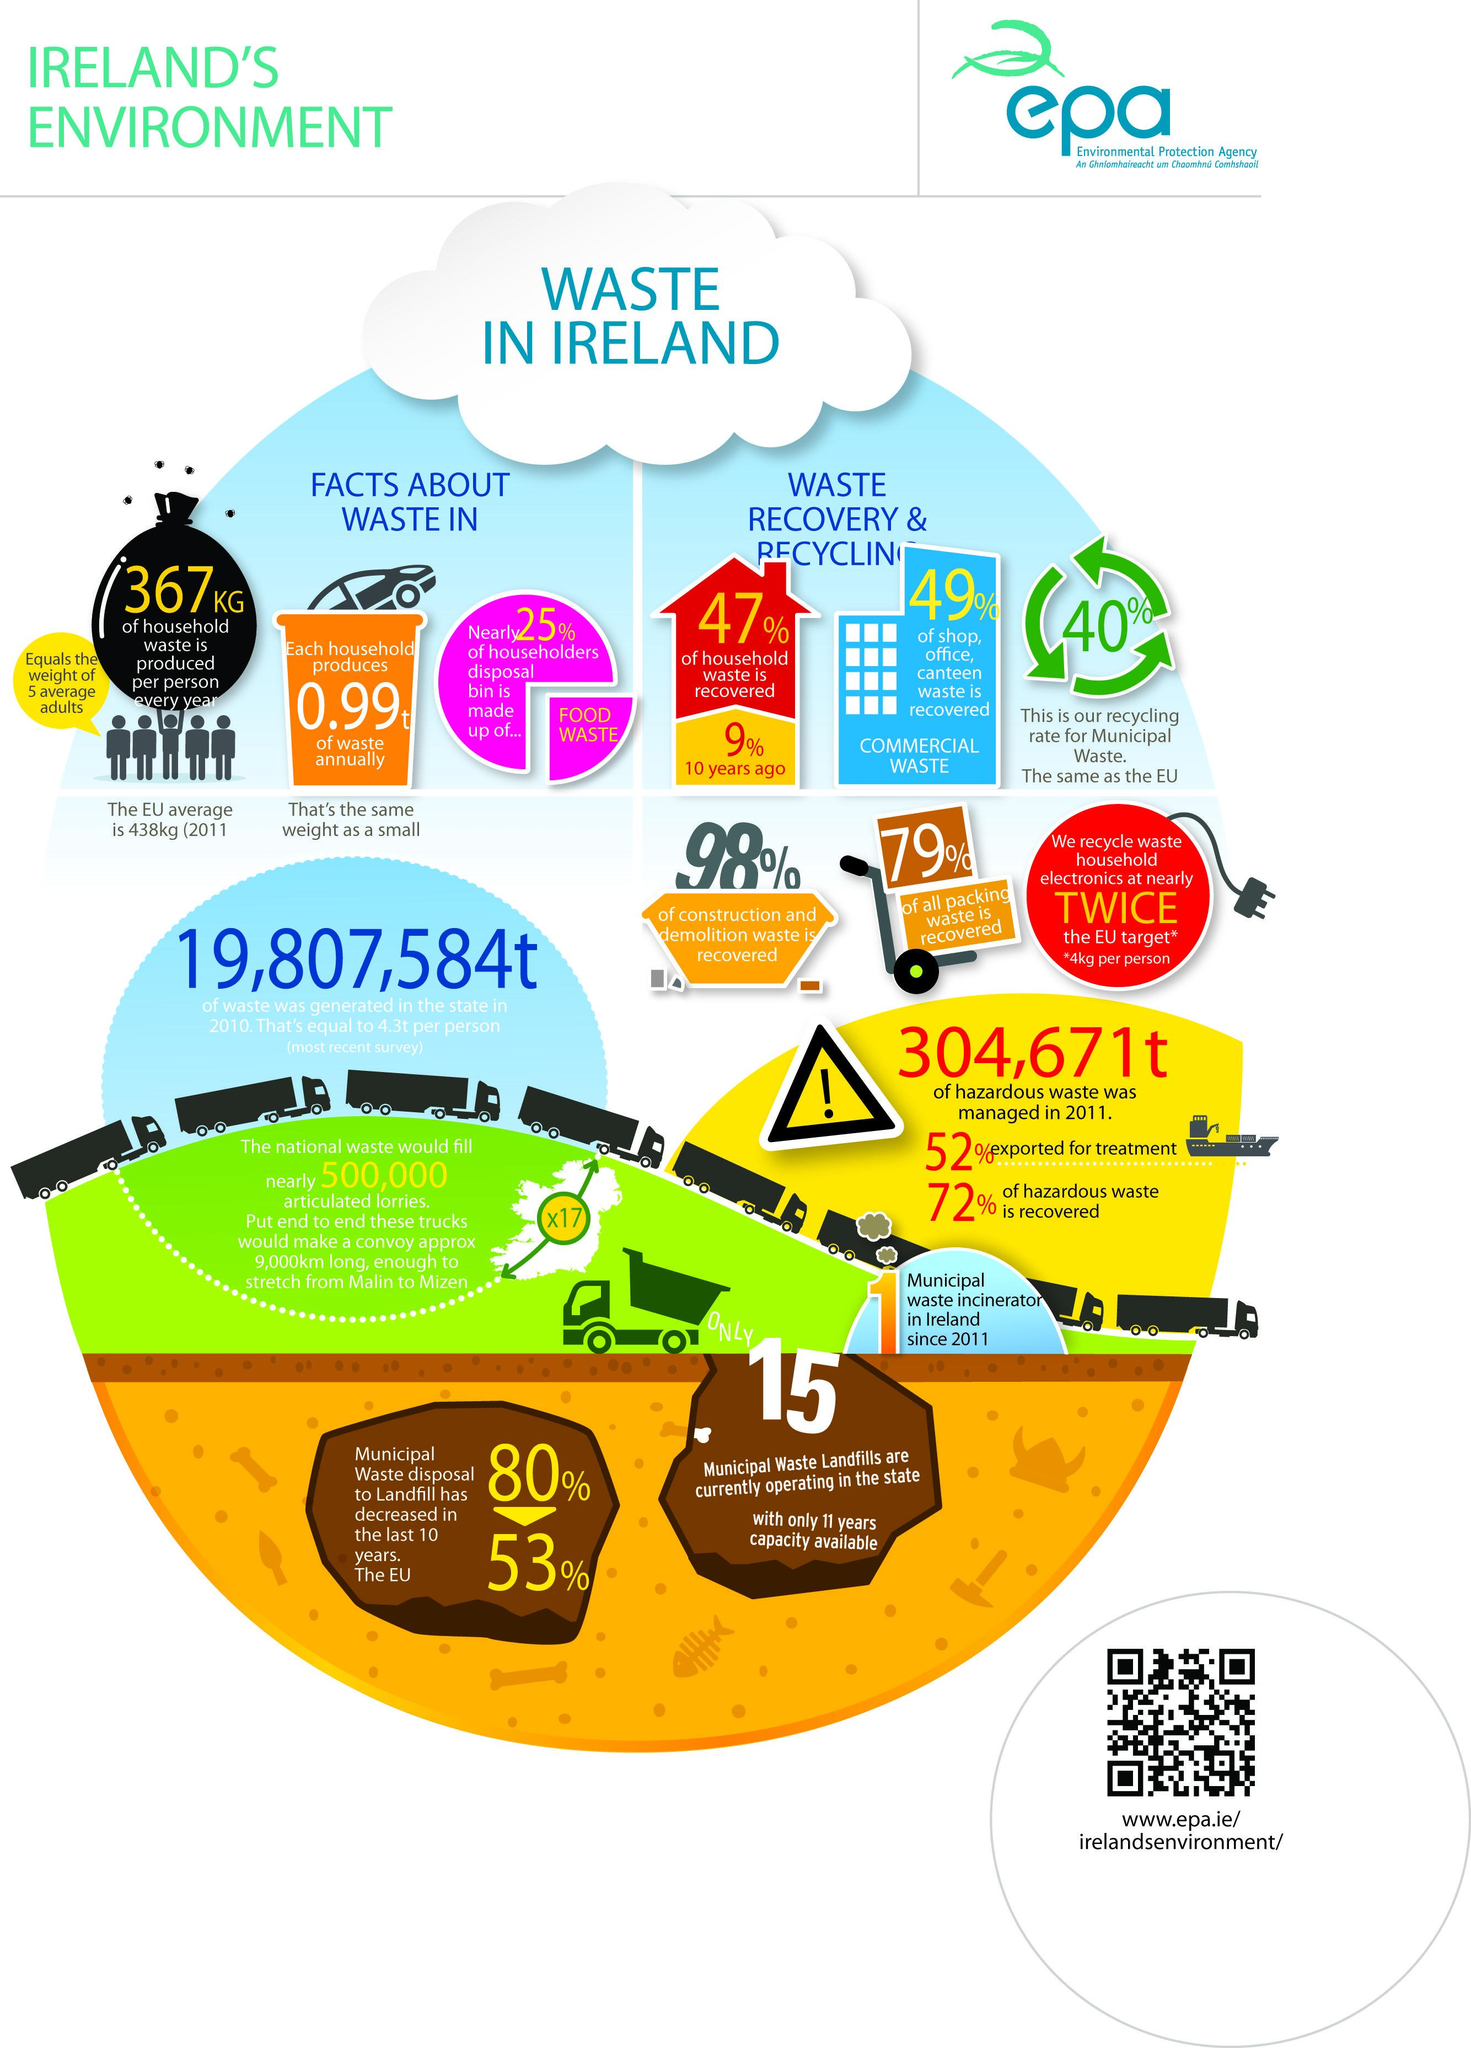List a handful of essential elements in this visual. The recycling rate for municipal waste in Ireland is approximately 40%. In the last 10 years, there has been a 53% decrease in the disposal of Municipal waste to landfill in Ireland. In Ireland, 98% of construction and demolition waste has been successfully recovered. In Ireland, a significant 49% of commercial waste has been successfully recovered. According to recent estimates, approximately 0.99 tons of household waste is generated in Ireland annually. 